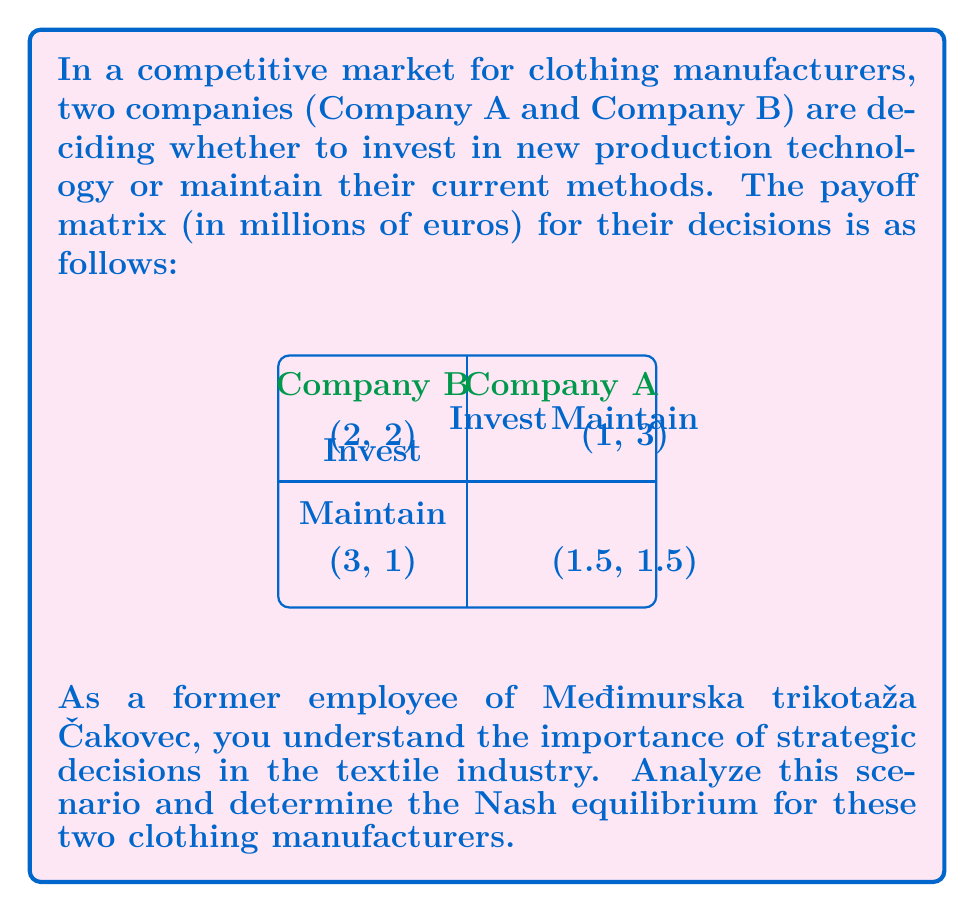Can you solve this math problem? To find the Nash equilibrium, we need to analyze each company's best response to the other company's strategy:

1. For Company A:
   - If B invests, A's best response is to invest (2 > 1)
   - If B maintains, A's best response is to invest (3 > 1.5)

2. For Company B:
   - If A invests, B's best response is to invest (2 > 1)
   - If A maintains, B's best response is to invest (3 > 1.5)

A Nash equilibrium occurs when both companies are playing their best response to the other's strategy. In this case, we can see that regardless of what the other company does, both Company A and Company B always prefer to invest.

Therefore, the Nash equilibrium is (Invest, Invest), resulting in a payoff of (2, 2) million euros for both companies.

This equilibrium reflects the competitive nature of the clothing manufacturing industry, where continuous investment in technology is often necessary to remain competitive, as would have been observed during the golden years of Međimurska trikotaža Čakovec.
Answer: (Invest, Invest) with payoffs (2, 2) 